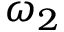Convert formula to latex. <formula><loc_0><loc_0><loc_500><loc_500>\omega _ { 2 }</formula> 